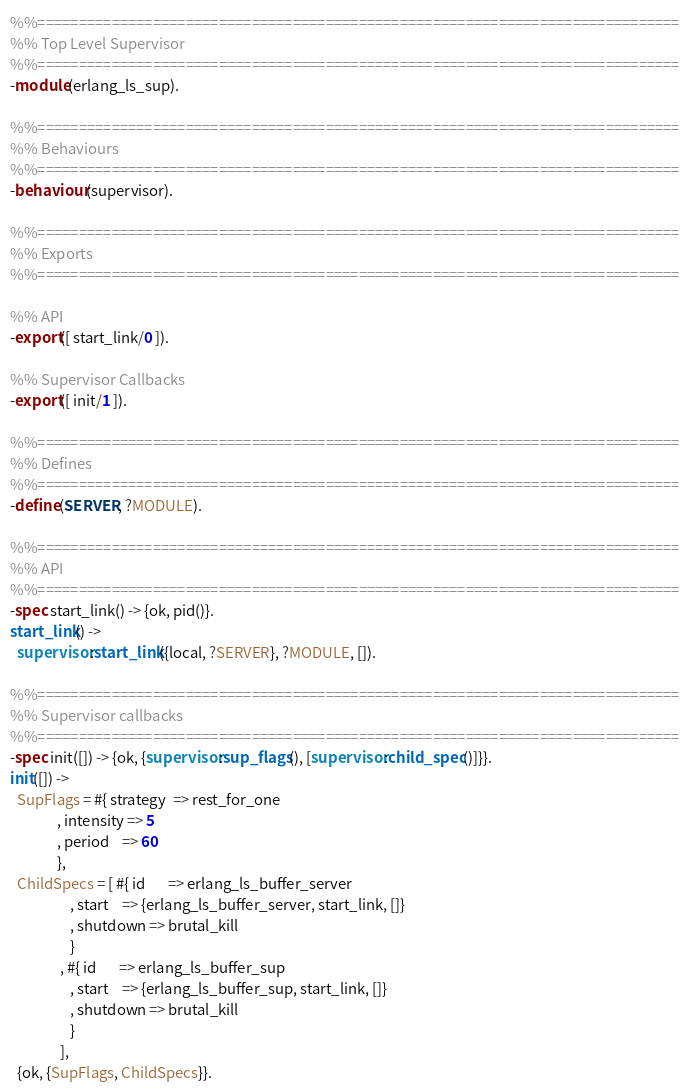<code> <loc_0><loc_0><loc_500><loc_500><_Erlang_>%%==============================================================================
%% Top Level Supervisor
%%==============================================================================
-module(erlang_ls_sup).

%%==============================================================================
%% Behaviours
%%==============================================================================
-behaviour(supervisor).

%%==============================================================================
%% Exports
%%==============================================================================

%% API
-export([ start_link/0 ]).

%% Supervisor Callbacks
-export([ init/1 ]).

%%==============================================================================
%% Defines
%%==============================================================================
-define(SERVER, ?MODULE).

%%==============================================================================
%% API
%%==============================================================================
-spec start_link() -> {ok, pid()}.
start_link() ->
  supervisor:start_link({local, ?SERVER}, ?MODULE, []).

%%==============================================================================
%% Supervisor callbacks
%%==============================================================================
-spec init([]) -> {ok, {supervisor:sup_flags(), [supervisor:child_spec()]}}.
init([]) ->
  SupFlags = #{ strategy  => rest_for_one
              , intensity => 5
              , period    => 60
              },
  ChildSpecs = [ #{ id       => erlang_ls_buffer_server
                  , start    => {erlang_ls_buffer_server, start_link, []}
                  , shutdown => brutal_kill
                  }
               , #{ id       => erlang_ls_buffer_sup
                  , start    => {erlang_ls_buffer_sup, start_link, []}
                  , shutdown => brutal_kill
                  }
               ],
  {ok, {SupFlags, ChildSpecs}}.
</code> 